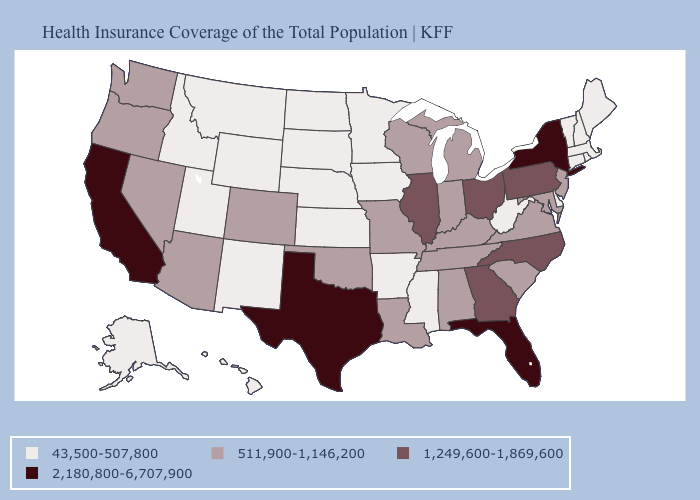Name the states that have a value in the range 1,249,600-1,869,600?
Give a very brief answer. Georgia, Illinois, North Carolina, Ohio, Pennsylvania. Among the states that border New York , which have the lowest value?
Concise answer only. Connecticut, Massachusetts, Vermont. Name the states that have a value in the range 43,500-507,800?
Give a very brief answer. Alaska, Arkansas, Connecticut, Delaware, Hawaii, Idaho, Iowa, Kansas, Maine, Massachusetts, Minnesota, Mississippi, Montana, Nebraska, New Hampshire, New Mexico, North Dakota, Rhode Island, South Dakota, Utah, Vermont, West Virginia, Wyoming. What is the value of Utah?
Quick response, please. 43,500-507,800. Does West Virginia have a lower value than California?
Answer briefly. Yes. Name the states that have a value in the range 43,500-507,800?
Be succinct. Alaska, Arkansas, Connecticut, Delaware, Hawaii, Idaho, Iowa, Kansas, Maine, Massachusetts, Minnesota, Mississippi, Montana, Nebraska, New Hampshire, New Mexico, North Dakota, Rhode Island, South Dakota, Utah, Vermont, West Virginia, Wyoming. Among the states that border Indiana , does Illinois have the lowest value?
Quick response, please. No. What is the lowest value in the USA?
Be succinct. 43,500-507,800. Among the states that border North Carolina , which have the lowest value?
Short answer required. South Carolina, Tennessee, Virginia. Does Maryland have the lowest value in the South?
Write a very short answer. No. What is the value of New Mexico?
Be succinct. 43,500-507,800. Among the states that border Indiana , does Kentucky have the lowest value?
Give a very brief answer. Yes. What is the value of Virginia?
Quick response, please. 511,900-1,146,200. Name the states that have a value in the range 511,900-1,146,200?
Write a very short answer. Alabama, Arizona, Colorado, Indiana, Kentucky, Louisiana, Maryland, Michigan, Missouri, Nevada, New Jersey, Oklahoma, Oregon, South Carolina, Tennessee, Virginia, Washington, Wisconsin. What is the value of Tennessee?
Give a very brief answer. 511,900-1,146,200. 